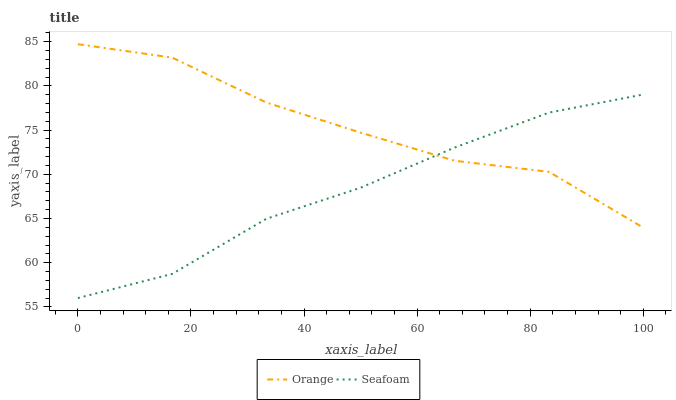Does Seafoam have the minimum area under the curve?
Answer yes or no. Yes. Does Orange have the maximum area under the curve?
Answer yes or no. Yes. Does Seafoam have the maximum area under the curve?
Answer yes or no. No. Is Seafoam the smoothest?
Answer yes or no. Yes. Is Orange the roughest?
Answer yes or no. Yes. Is Seafoam the roughest?
Answer yes or no. No. Does Seafoam have the lowest value?
Answer yes or no. Yes. Does Orange have the highest value?
Answer yes or no. Yes. Does Seafoam have the highest value?
Answer yes or no. No. Does Seafoam intersect Orange?
Answer yes or no. Yes. Is Seafoam less than Orange?
Answer yes or no. No. Is Seafoam greater than Orange?
Answer yes or no. No. 